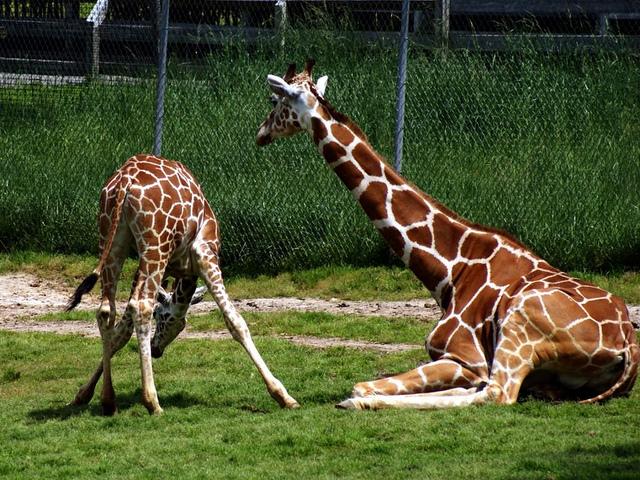What is surrounding the sitting giraffe?
Keep it brief. Fence. Are both animals standing up?
Concise answer only. No. Are both of these animals adults?
Answer briefly. No. What animal is this?
Concise answer only. Giraffe. 